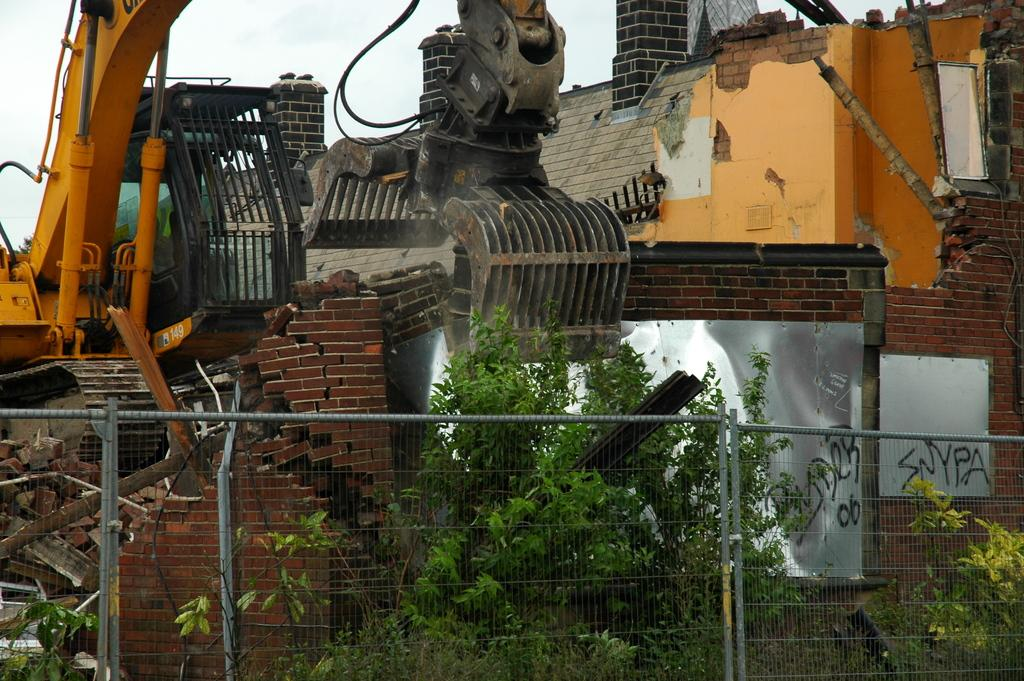What is the main subject of the image? There is a crane in the image. What is the crane doing in the image? The crane is destroying a house. What can be seen at the bottom of the image? There is a fence at the bottom of the image, and there are many bricks as well. What type of vegetation is near the fence? There are trees beside the fence. What advice is your mom giving during the discussion in the image? There is no discussion or mom present in the image; it features a crane destroying a house. 